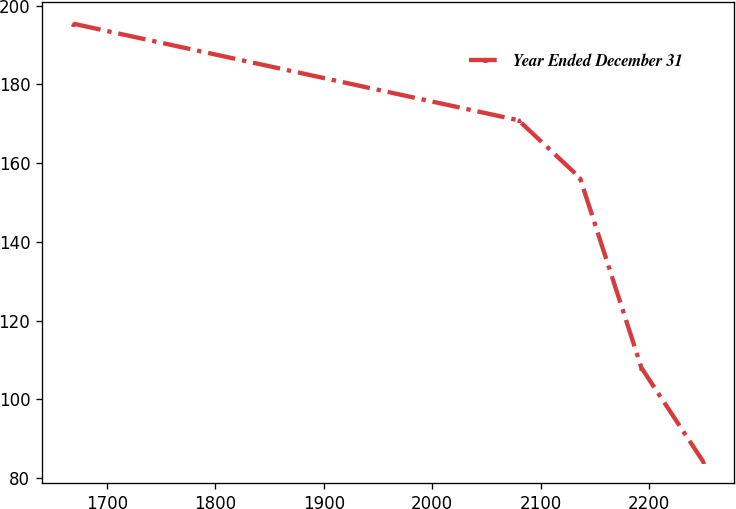<chart> <loc_0><loc_0><loc_500><loc_500><line_chart><ecel><fcel>Year Ended December 31<nl><fcel>1669.12<fcel>195.41<nl><fcel>2079.66<fcel>170.88<nl><fcel>2136.33<fcel>156.25<nl><fcel>2193<fcel>107.99<nl><fcel>2249.67<fcel>84.29<nl></chart> 